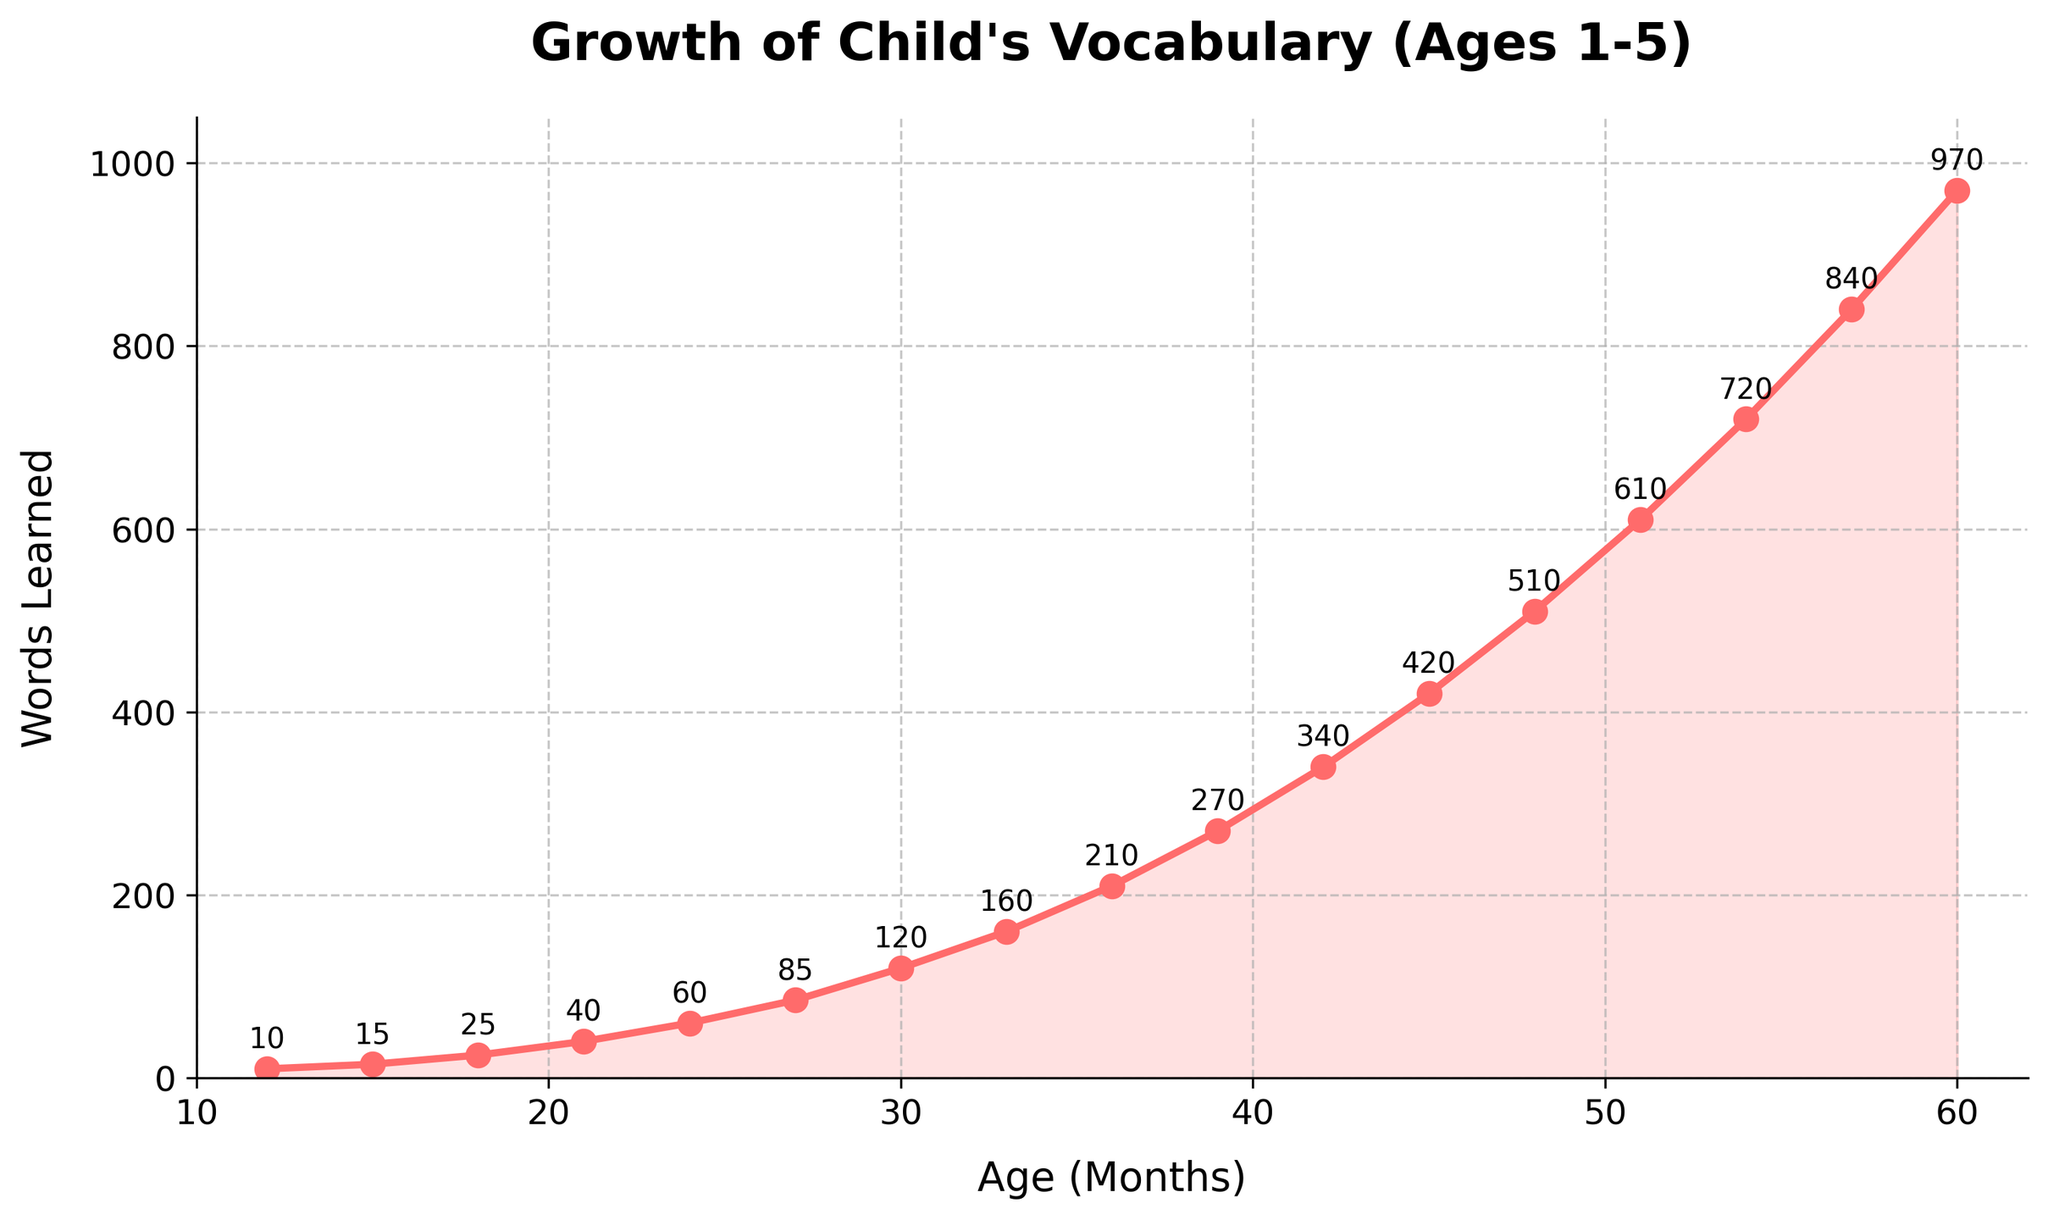What is the number of words learned at age 2 (24 months)? The age is 24 months, so we find the corresponding point on the x-axis and look at the y-axis value, which shows words learned.
Answer: 60 How many months did it take for the child's vocabulary to reach 120 words? We need to find the point on the y-axis where words learned is 120 and trace horizontally to see the corresponding month on the x-axis.
Answer: 30 At what age does the child learn 510 words? We locate the 510 words on the y-axis and move horizontally to see the matching x-axis value to find the age in months.
Answer: 48 What is the difference in words learned between ages 18 months and 27 months? First, find the words learned at 18 months (25) and at 27 months (85). Then, calculate the difference by subtracting the two values (85 - 25).
Answer: 60 By how much did words learned increase from age 15 to age 21 months? Find the values for both ages (15 months: 15 words, 21 months: 40 words) and subtract the former from the latter (40 - 15).
Answer: 25 Which age shows the fastest rate of increase in vocabulary, based on the steepest part of the line? Visually find the steepest section of the line graph, indicating the fastest increase. This occurs between 51 and 54 months (610 to 720 words).
Answer: 51 to 54 months What is the average number of words learned per month between ages 36 and 60 months? Calculate the total words learned at 60 months (970) minus the words learned at 36 months (210), then divide by the number of months (60 - 36). This is (970 - 210) / 24.
Answer: 31.67 Compare the number of words learned at ages 12 and 15 months. Which age has more words learned? Find the words learned at 12 months (10) and at 15 months (15), then compare the two values.
Answer: 15 months How many more words did the child learn from 42 to 54 months than from 30 to 42 months? Find the words learned at each month and calculate the difference for both periods (42 - 54: 720 - 340, 30 - 42: 340 - 120). Subtract the two differences (380 - 220).
Answer: 160 What is the total number of words learned between ages 27 and 39 months? Find the words learned at 27 months (85) and at 39 months (270), then sum the differences for each month increment. (85 + 35 + 40 + 50 + 60 = 270).
Answer: 185 